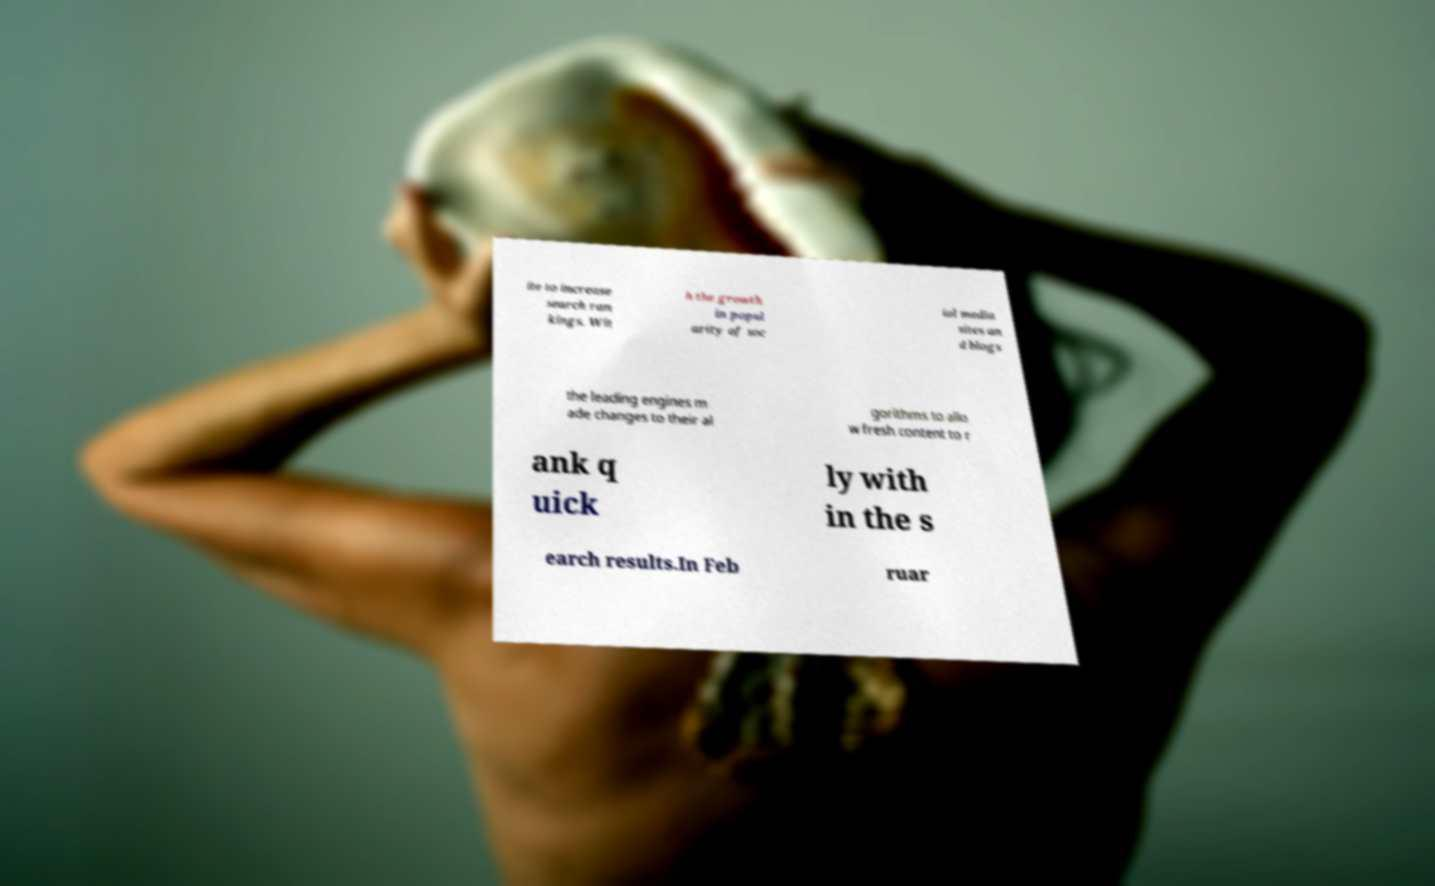Please identify and transcribe the text found in this image. ite to increase search ran kings. Wit h the growth in popul arity of soc ial media sites an d blogs the leading engines m ade changes to their al gorithms to allo w fresh content to r ank q uick ly with in the s earch results.In Feb ruar 